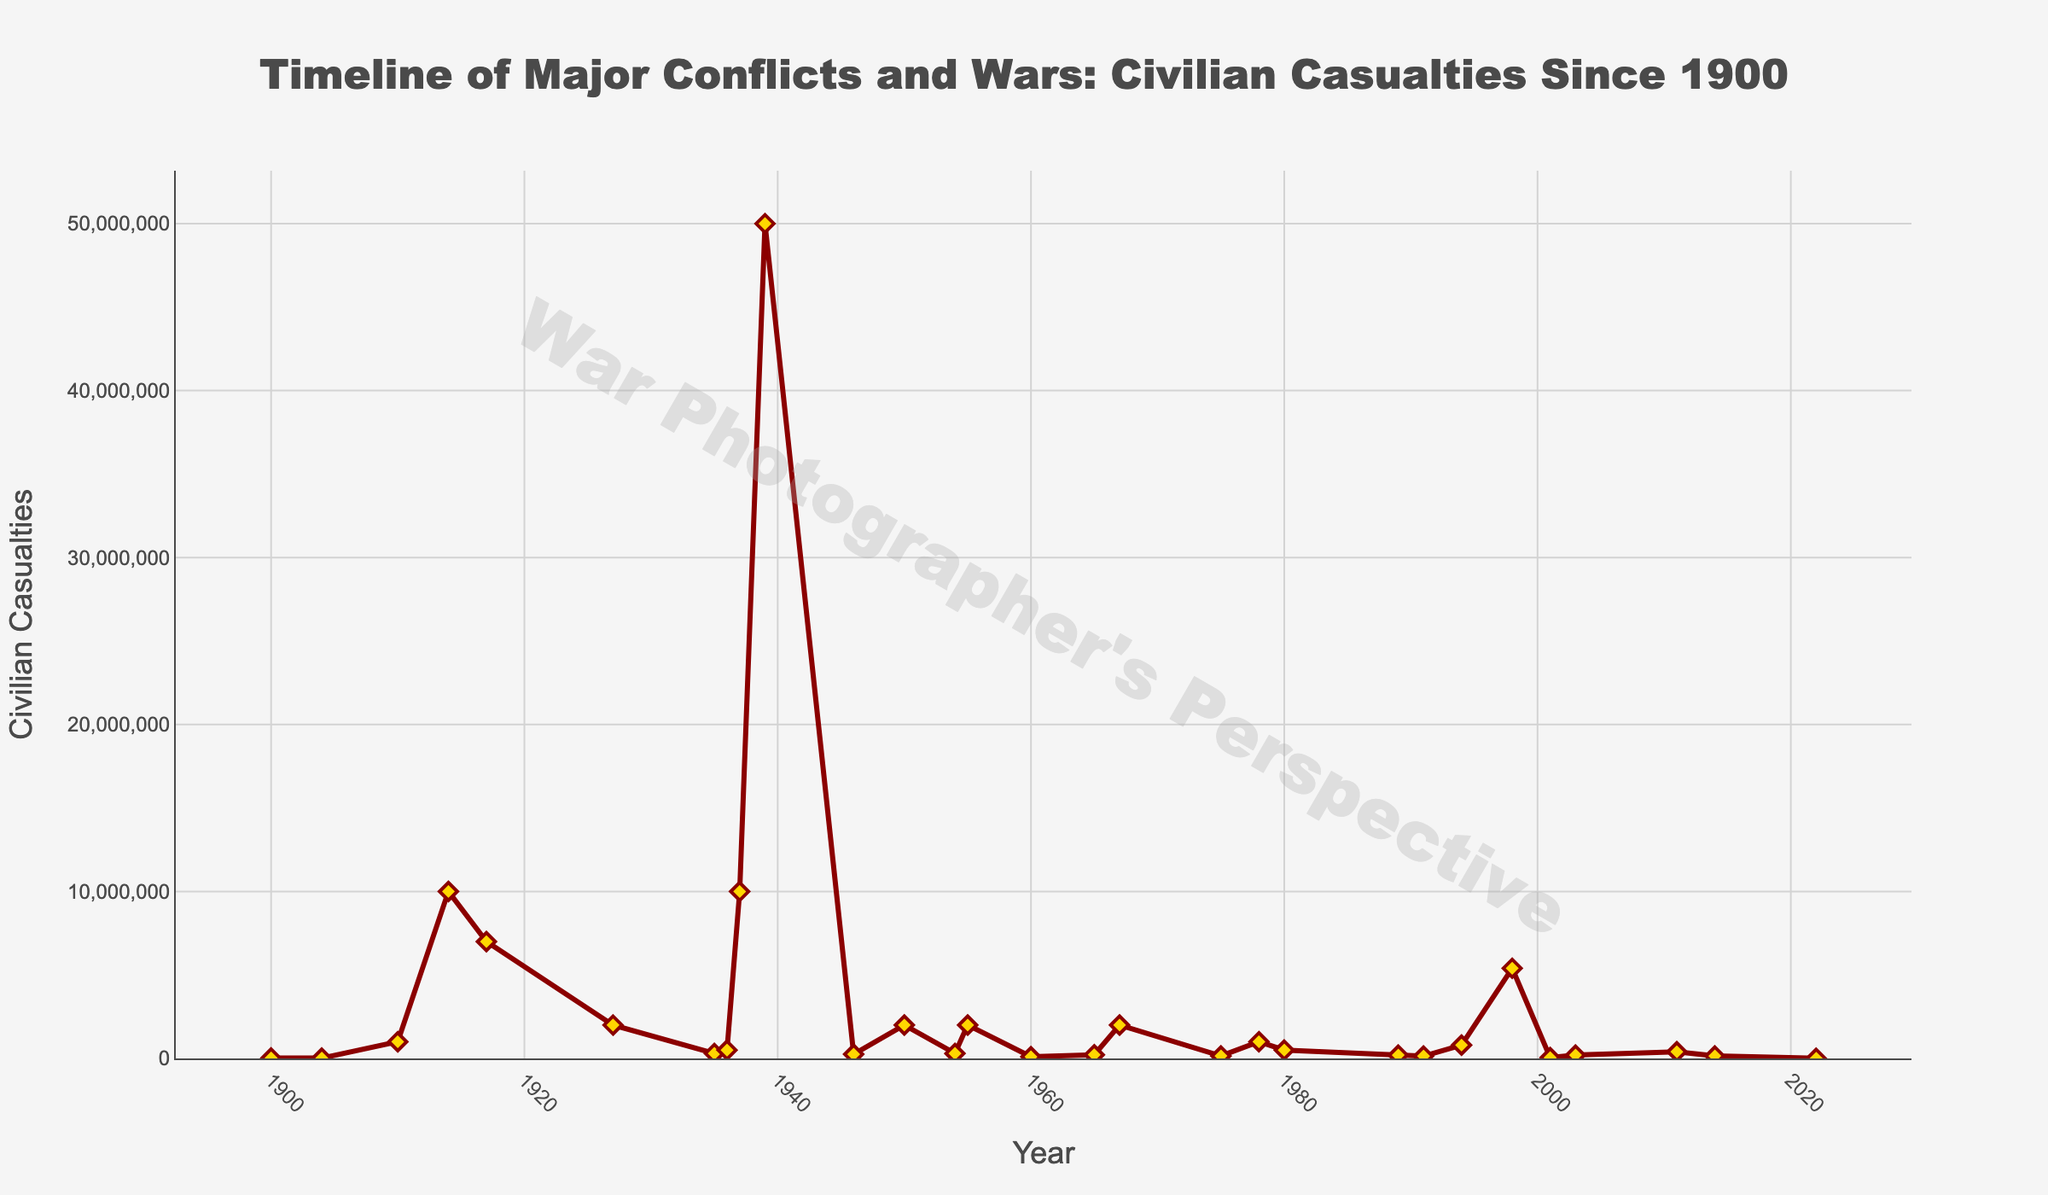Which conflict resulted in the highest number of civilian casualties? The highest peak in the timeline represents the conflict with the highest number of civilian casualties. In this case, World War II in 1939 stands out with 50,000,000 civilian casualties.
Answer: World War II What are the civilian casualties for the conflicts that occurred in 1910, 1914, and 1917? To answer this, look at the points on the timeline for the years 1910, 1914, and 1917. The civilian casualties are 1,000,000 for the Mexican Revolution in 1910, 10,000,000 for World War I in 1914, and 7,000,000 for the Russian Civil War in 1917.
Answer: 1,000,000, 10,000,000, 7,000,000 Which conflict between 2000 and 2022 had the least number of civilian casualties? Observing the timeline for the period between 2000 and 2022, the conflict with the least number of civilian casualties is the Russian Invasion of Ukraine in 2022 with 10,000 casualties.
Answer: Russian Invasion of Ukraine What is the total number of civilian casualties from the Second Sino-Japanese War and World War II? Summing the civilian casualties for the Second Sino-Japanese War (10,000,000) and World War II (50,000,000), the total is 60,000,000.
Answer: 60,000,000 How many conflicts have civilian casualties exceeding 2,000,000? By observing the vertical lines of the timeline, count the conflicts with peaks above the 2,000,000 mark. The conflicts are: World War I, Russian Civil War, Chinese Civil War, Second Sino-Japanese War, World War II, Nigerian Civil War, and the Second Congo War, a total of 7 conflicts.
Answer: 7 Which conflict caused more civilian casualties, the Vietnam War or the Syrian Civil War? Compare the points on the timeline for the Vietnam War (2,000,000) and the Syrian Civil War (400,000). The Vietnam War resulted in more civilian casualties.
Answer: Vietnam War When comparing the Korean War and the First Indochina War, which had a higher number of civilian casualties? Observing the points on the timeline, the Korean War had 2,000,000 civilian casualties, while the First Indochina War had 250,000. Therefore, the Korean War had higher casualties.
Answer: Korean War What trend do you observe in the number of civilian casualties from 1900 to 1940? By following the timeline from 1900 to 1940, there is a noticeable increasing trend, culminating in the enormous spike during World War II in 1939.
Answer: Increasing What is the average number of civilian casualties for conflicts that occurred between 1980 and 2000? First, identify the conflicts between 1980 and 2000: Iran-Iraq War (500,000), First Liberian Civil War (200,000), Yugoslav Wars (140,000), Rwandan Genocide (800,000), and Second Congo War (5,400,000). Sum up the casualties (500,000 + 200,000 + 140,000 + 800,000 + 5,400,000 = 7,040,000) and divide by the number of conflicts (5) to get an average of 1,408,000.
Answer: 1,408,000 Which conflict between 1900 and 1950 had the smallest number of civilian casualties? Check the points on the timeline for conflicts between 1900 and 1950. The Second Boer War in 1900 had 26,000 casualties, which is the smallest number.
Answer: Second Boer War 